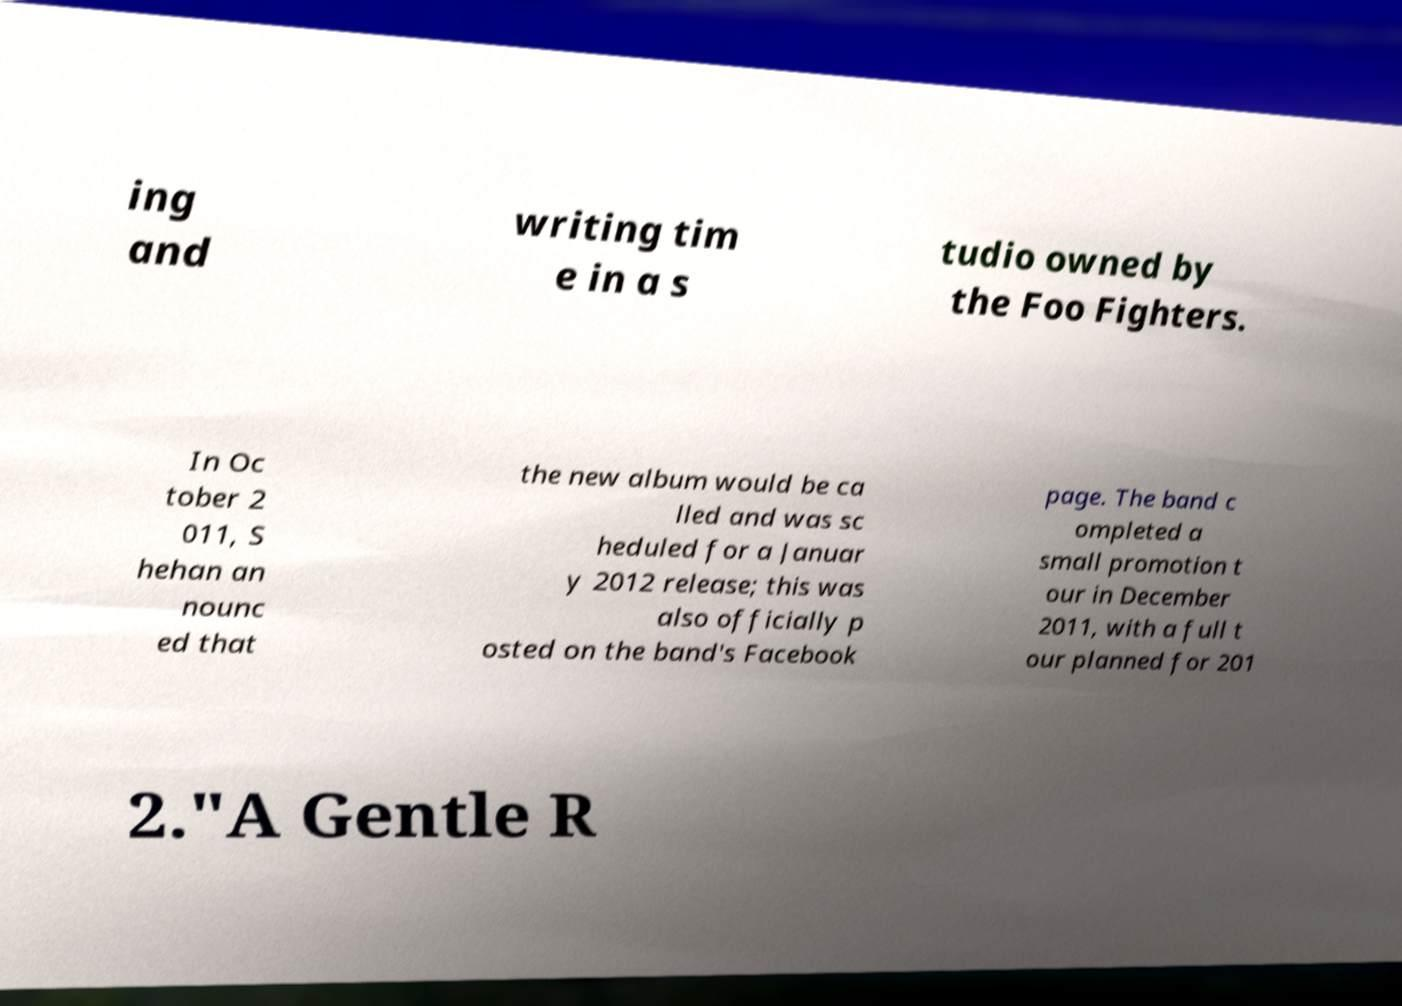Can you read and provide the text displayed in the image?This photo seems to have some interesting text. Can you extract and type it out for me? ing and writing tim e in a s tudio owned by the Foo Fighters. In Oc tober 2 011, S hehan an nounc ed that the new album would be ca lled and was sc heduled for a Januar y 2012 release; this was also officially p osted on the band's Facebook page. The band c ompleted a small promotion t our in December 2011, with a full t our planned for 201 2."A Gentle R 